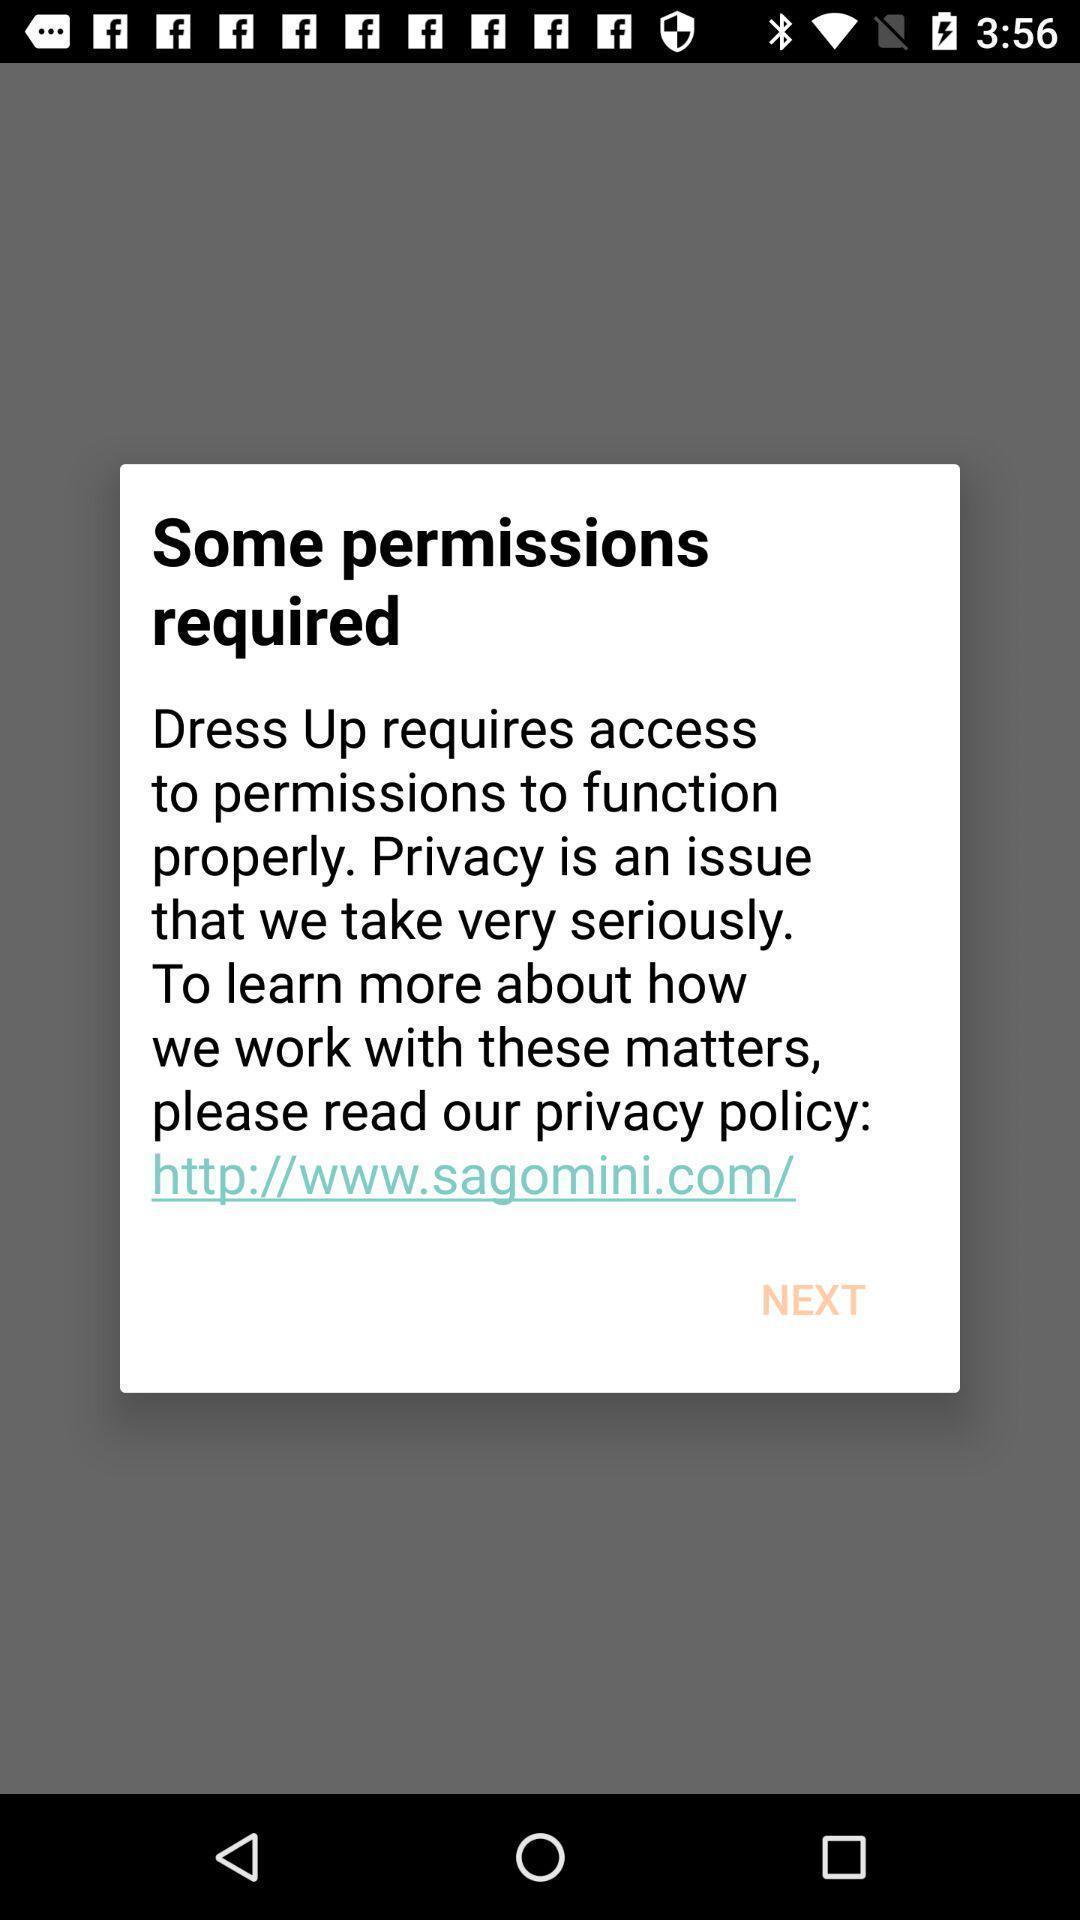Summarize the information in this screenshot. Pop-up to to access permissions in application. 